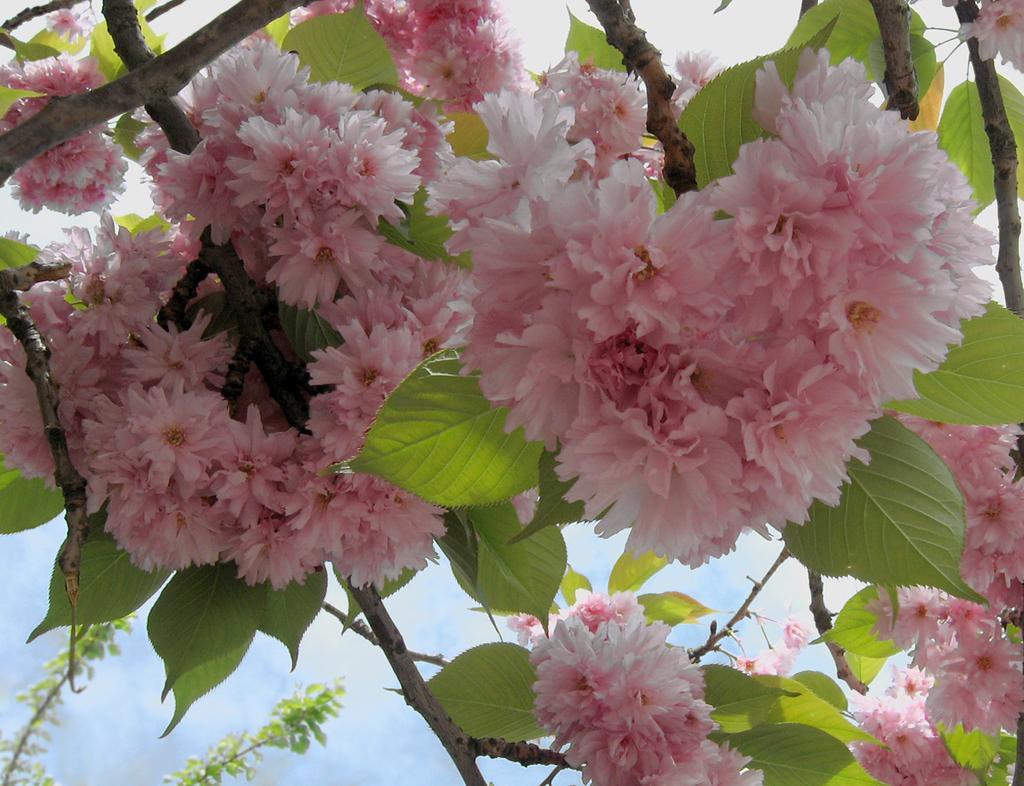How would you summarize this image in a sentence or two? In this picture I can see steps on which there are leaves and flowers and in the background I see the sky. 